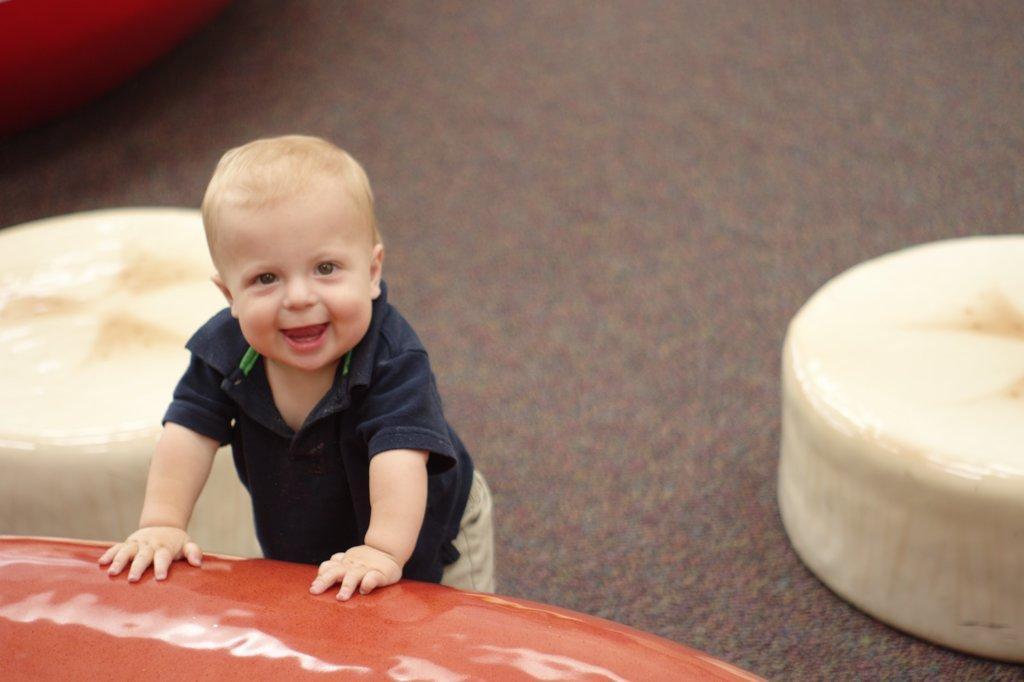Can you describe this image briefly? In this image there is a kid with a smile on his face is leaning on to an object. 